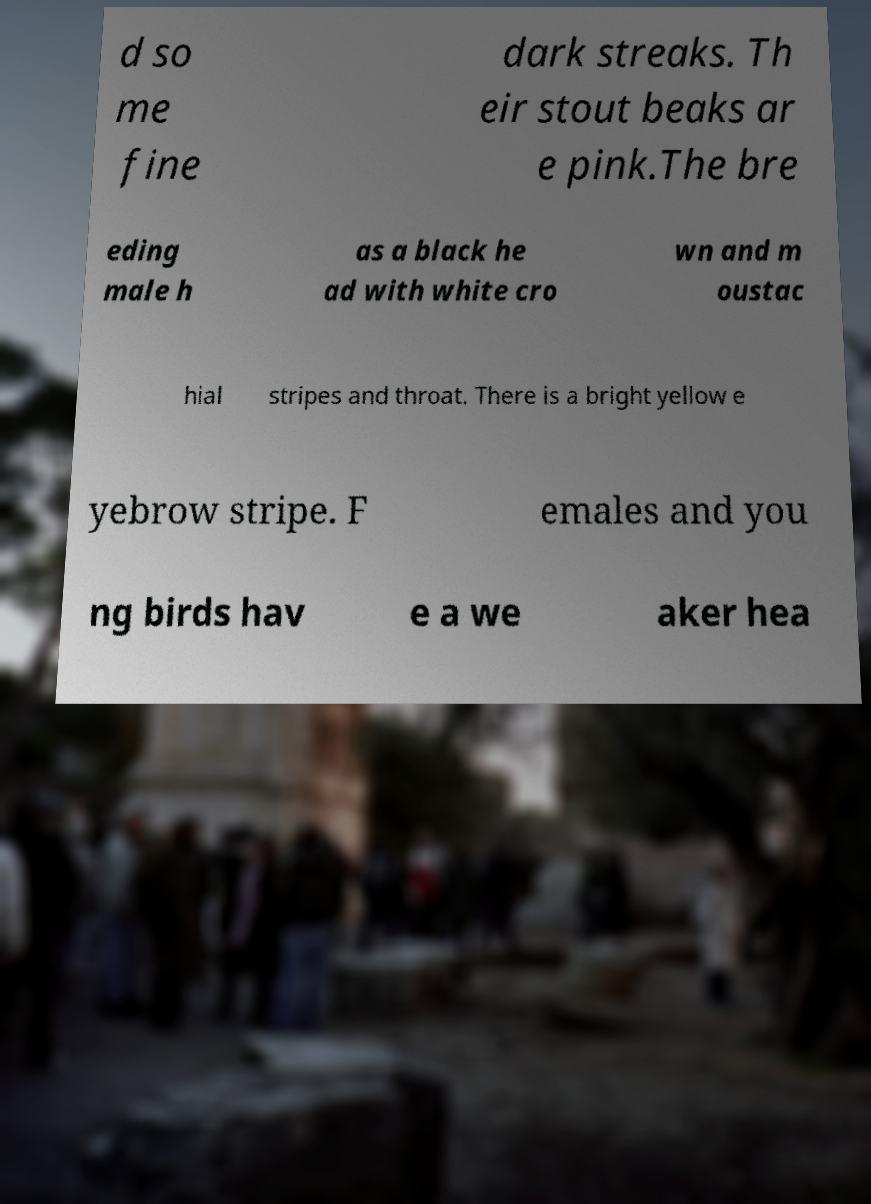Could you assist in decoding the text presented in this image and type it out clearly? d so me fine dark streaks. Th eir stout beaks ar e pink.The bre eding male h as a black he ad with white cro wn and m oustac hial stripes and throat. There is a bright yellow e yebrow stripe. F emales and you ng birds hav e a we aker hea 